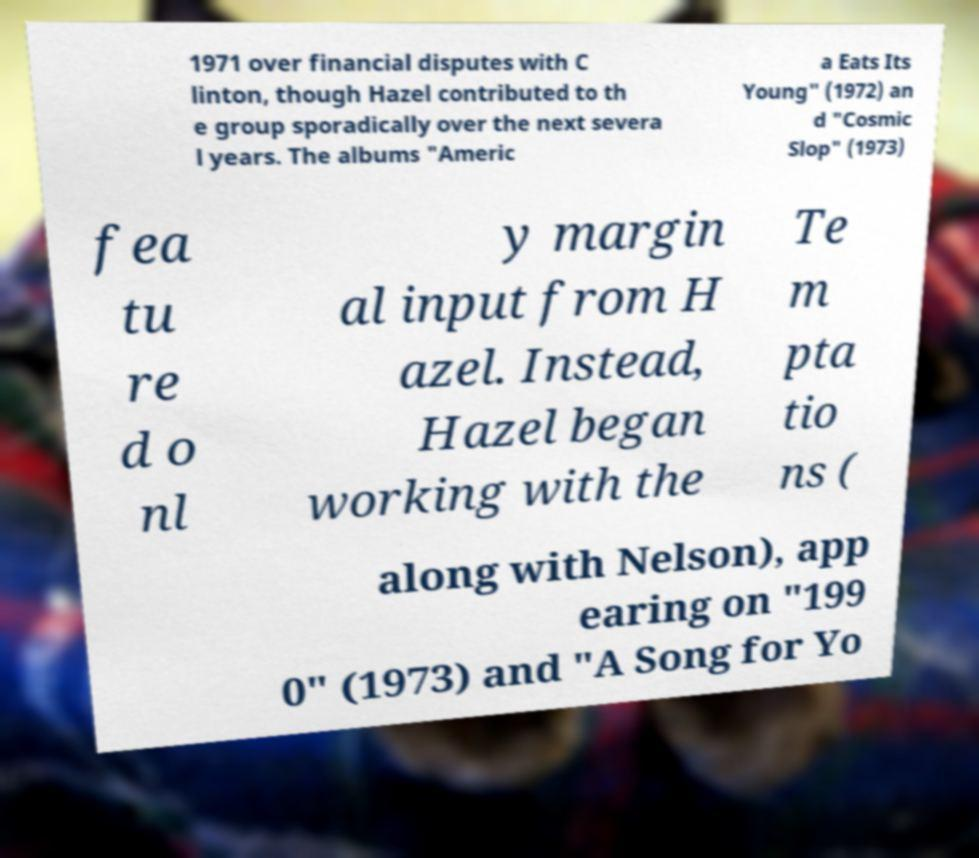Please identify and transcribe the text found in this image. 1971 over financial disputes with C linton, though Hazel contributed to th e group sporadically over the next severa l years. The albums "Americ a Eats Its Young" (1972) an d "Cosmic Slop" (1973) fea tu re d o nl y margin al input from H azel. Instead, Hazel began working with the Te m pta tio ns ( along with Nelson), app earing on "199 0" (1973) and "A Song for Yo 